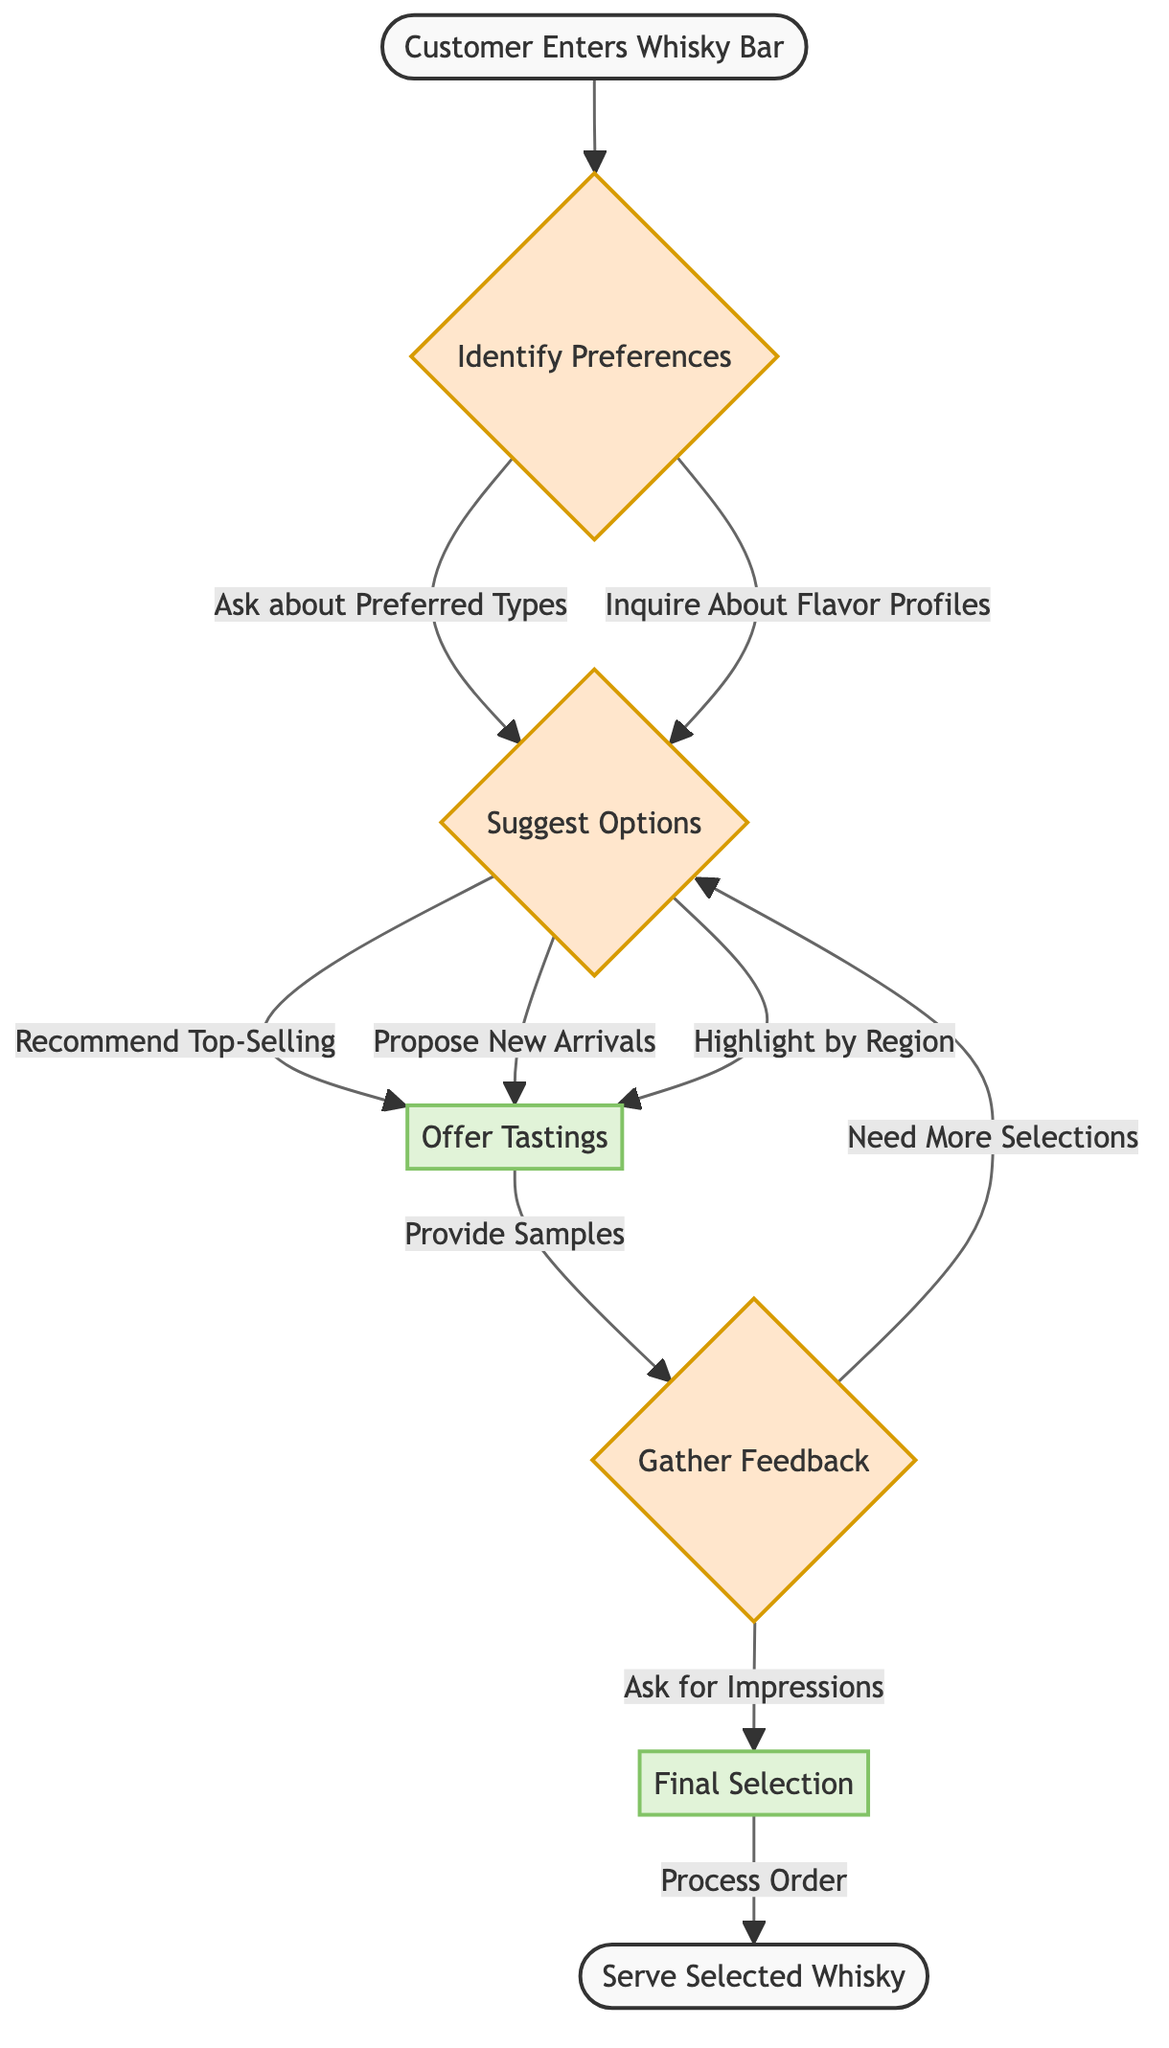What is the first step in the process? The first step in the process, as indicated in the flowchart, is "Customer Enters Whisky Bar." This is the starting point of the selection process.
Answer: Customer Enters Whisky Bar How many options are suggested after identifying preferences? After identifying preferences, the diagram shows three options that can be suggested: "Recommend Top-Selling Whiskies," "Propose New Arrivals," and "Highlight Whiskies by Region." Thus, there are three options in total.
Answer: 3 What happens after offering tastings? After offering tastings, the next step is to "Gather Feedback." This indicates that customer impressions are collected following the tasting.
Answer: Gather Feedback If the customer needs more selections, what is the next step? If the customer indicates that more selections are needed, the diagram directs back to "Suggest Options." This shows the iterative nature of the process based on customer feedback.
Answer: Suggest Options What is the final action taken in the process? The final action taken in the process is "Serve Selected Whisky." This is the endpoint of the flow and concludes the whisky selection process.
Answer: Serve Selected Whisky What are the two inquiries made to identify customer preferences? To identify customer preferences, the diagram specifies two inquiries: "Ask about Preferred Whisky Types" and "Inquire About Flavor Profiles." These inquiries help tailor the selection to customer tastes.
Answer: Ask about Preferred Whisky Types, Inquire About Flavor Profiles How does the process proceed from the final selection? From the final selection, the process proceeds to "Process Order," which is the next step before reaching the end of the flow. This shows a direct action taken after making a whisky selection.
Answer: Process Order 